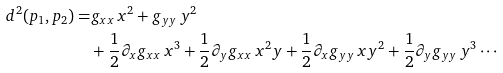Convert formula to latex. <formula><loc_0><loc_0><loc_500><loc_500>d ^ { 2 } ( p _ { 1 } , p _ { 2 } ) = & g _ { x x } \, x ^ { 2 } + g _ { y y } \, y ^ { 2 } \\ & + \frac { 1 } { 2 } \partial _ { x } g _ { x x } \, x ^ { 3 } + \frac { 1 } { 2 } \partial _ { y } g _ { x x } \, x ^ { 2 } y + \frac { 1 } { 2 } \partial _ { x } g _ { y y } \, x y ^ { 2 } + \frac { 1 } { 2 } \partial _ { y } g _ { y y } \, y ^ { 3 } \cdots</formula> 